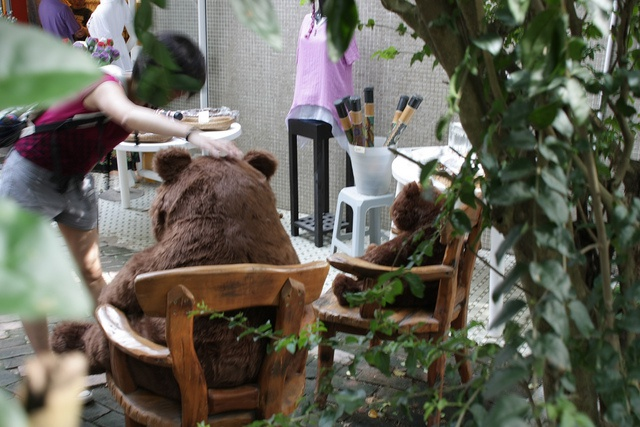Describe the objects in this image and their specific colors. I can see chair in gray, black, maroon, and white tones, bear in gray, black, and maroon tones, people in gray, black, darkgray, and lightgray tones, chair in gray, black, darkgreen, and maroon tones, and teddy bear in gray, black, darkgreen, and maroon tones in this image. 